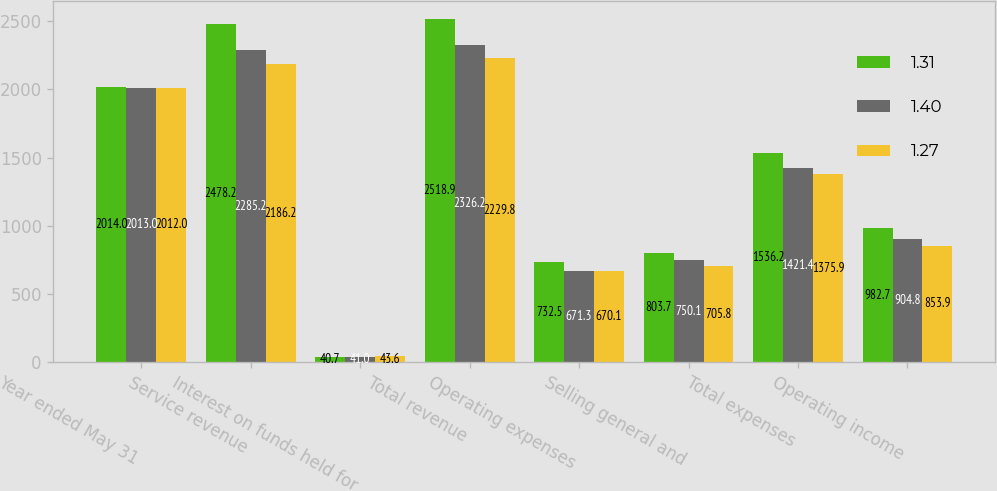Convert chart. <chart><loc_0><loc_0><loc_500><loc_500><stacked_bar_chart><ecel><fcel>Year ended May 31<fcel>Service revenue<fcel>Interest on funds held for<fcel>Total revenue<fcel>Operating expenses<fcel>Selling general and<fcel>Total expenses<fcel>Operating income<nl><fcel>1.31<fcel>2014<fcel>2478.2<fcel>40.7<fcel>2518.9<fcel>732.5<fcel>803.7<fcel>1536.2<fcel>982.7<nl><fcel>1.4<fcel>2013<fcel>2285.2<fcel>41<fcel>2326.2<fcel>671.3<fcel>750.1<fcel>1421.4<fcel>904.8<nl><fcel>1.27<fcel>2012<fcel>2186.2<fcel>43.6<fcel>2229.8<fcel>670.1<fcel>705.8<fcel>1375.9<fcel>853.9<nl></chart> 